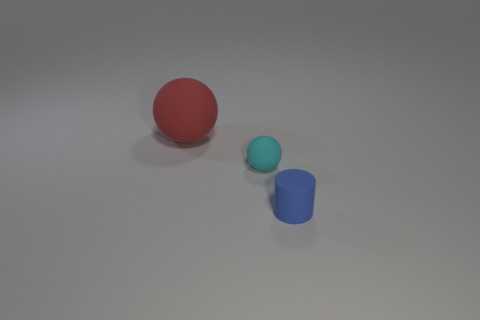Do the tiny cyan object and the cylinder have the same material? Based on the image, the tiny cyan object and the cylinder appear to have a similar matte finish, indicating that they could indeed be made of the same or very similar materials. They both display a lack of reflective properties one might associate with metallic or glossy finishes, suggesting a plastic or similarly textured composite. 